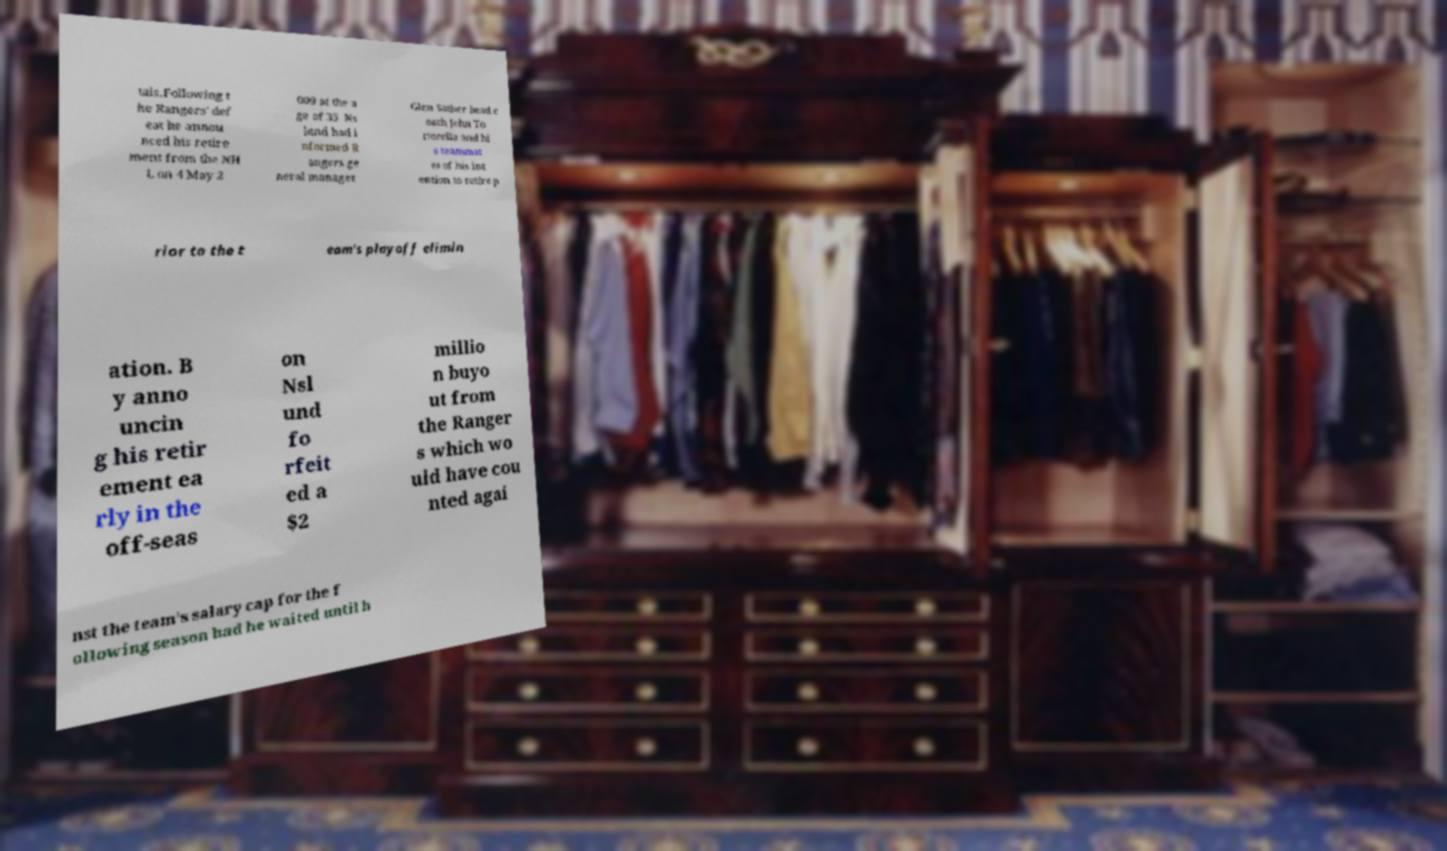I need the written content from this picture converted into text. Can you do that? tals.Following t he Rangers' def eat he annou nced his retire ment from the NH L on 4 May 2 009 at the a ge of 35. Ns lund had i nformed R angers ge neral manager Glen Sather head c oach John To rtorella and hi s teammat es of his int ention to retire p rior to the t eam's playoff elimin ation. B y anno uncin g his retir ement ea rly in the off-seas on Nsl und fo rfeit ed a $2 millio n buyo ut from the Ranger s which wo uld have cou nted agai nst the team's salary cap for the f ollowing season had he waited until h 